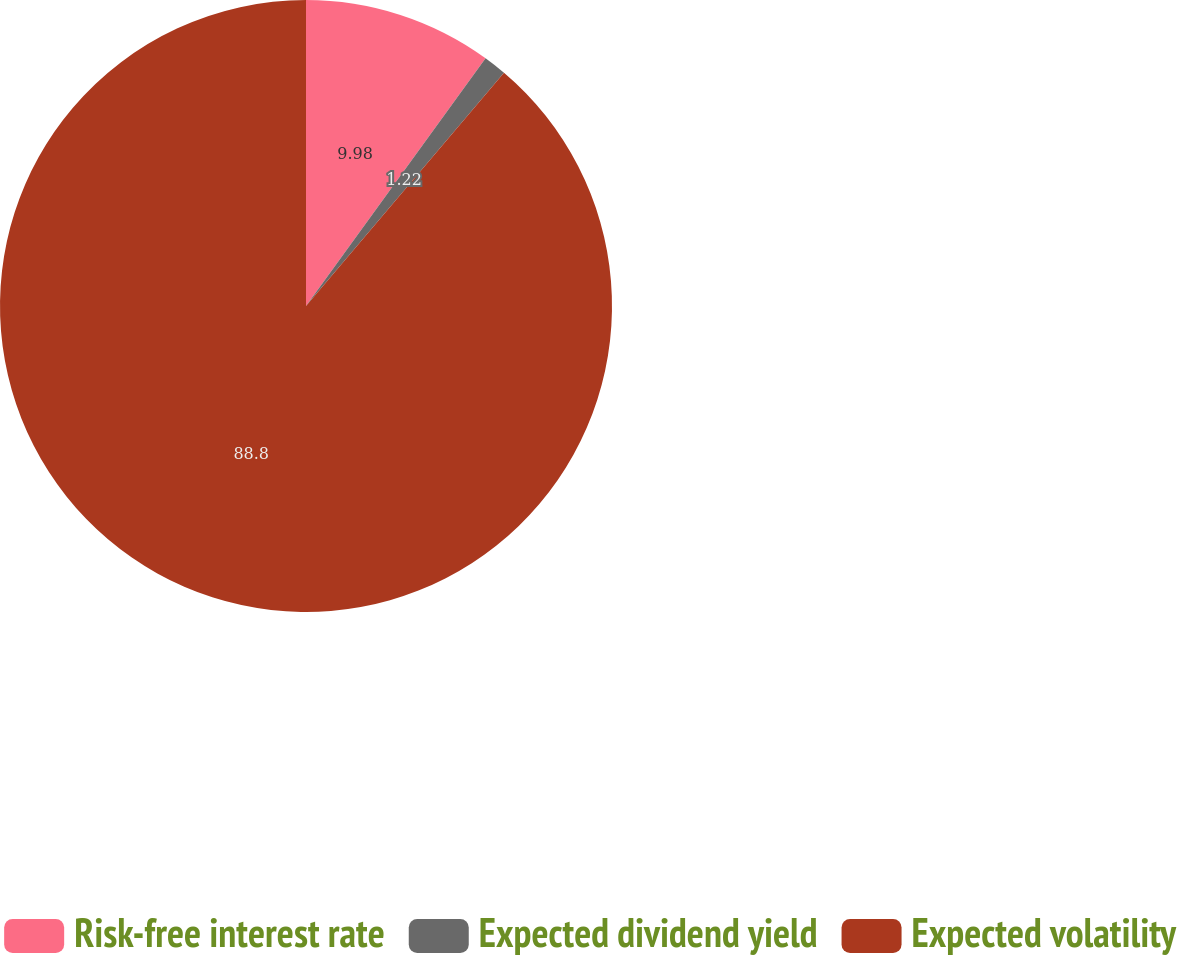Convert chart. <chart><loc_0><loc_0><loc_500><loc_500><pie_chart><fcel>Risk-free interest rate<fcel>Expected dividend yield<fcel>Expected volatility<nl><fcel>9.98%<fcel>1.22%<fcel>88.8%<nl></chart> 